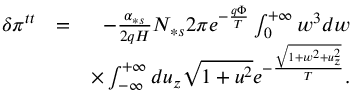Convert formula to latex. <formula><loc_0><loc_0><loc_500><loc_500>\begin{array} { r l r } { \delta \pi ^ { t t } } & { = } & { - \frac { \alpha _ { \ast s } } { 2 q H } N _ { \ast s } 2 \pi e ^ { - \frac { q \Phi } { T } } \int _ { 0 } ^ { + \infty } w ^ { 3 } d w } \\ & { \times \int _ { - \infty } ^ { + \infty } d u _ { z } \sqrt { 1 + u ^ { 2 } } e ^ { - \frac { \sqrt { 1 + w ^ { 2 } + u _ { z } ^ { 2 } } } { T } } . } \end{array}</formula> 